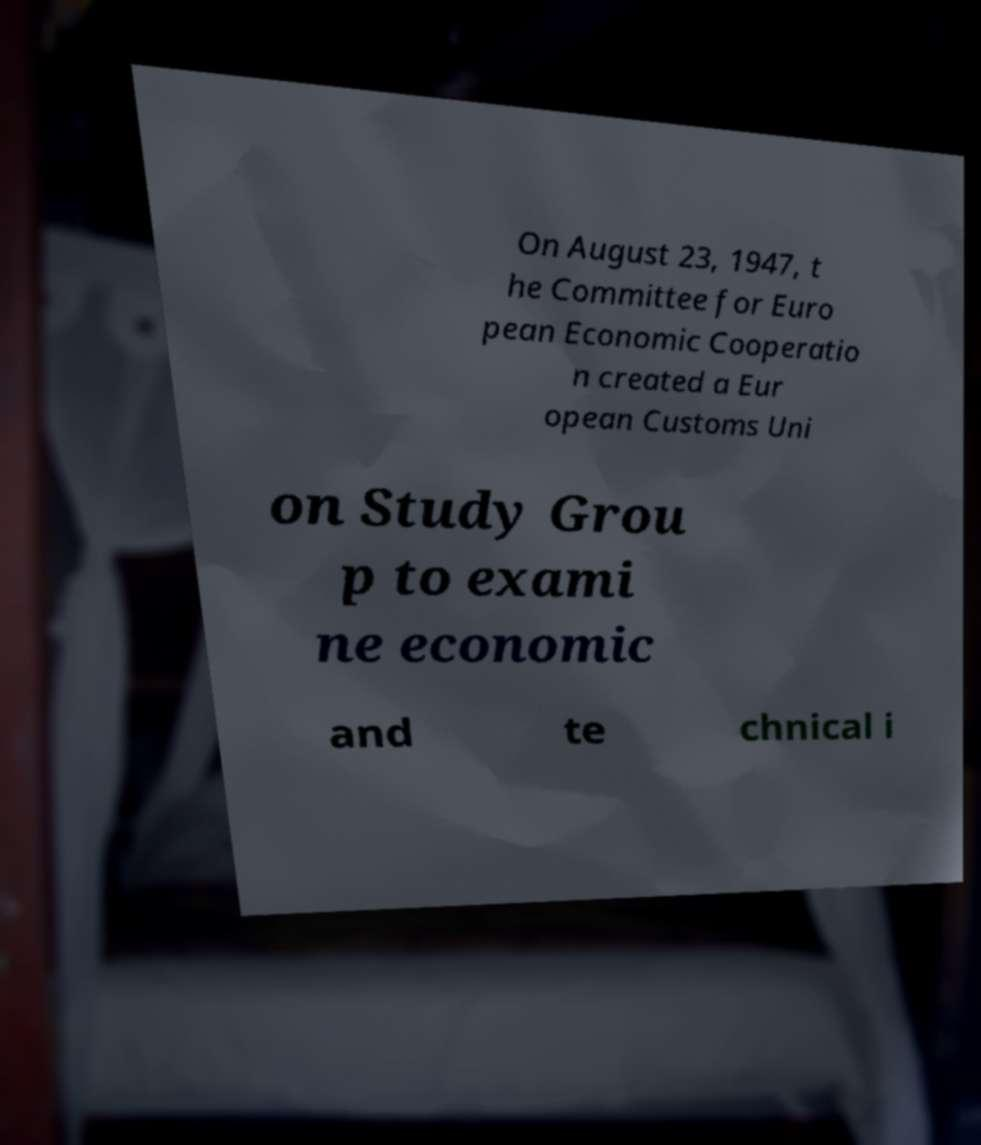Can you accurately transcribe the text from the provided image for me? On August 23, 1947, t he Committee for Euro pean Economic Cooperatio n created a Eur opean Customs Uni on Study Grou p to exami ne economic and te chnical i 